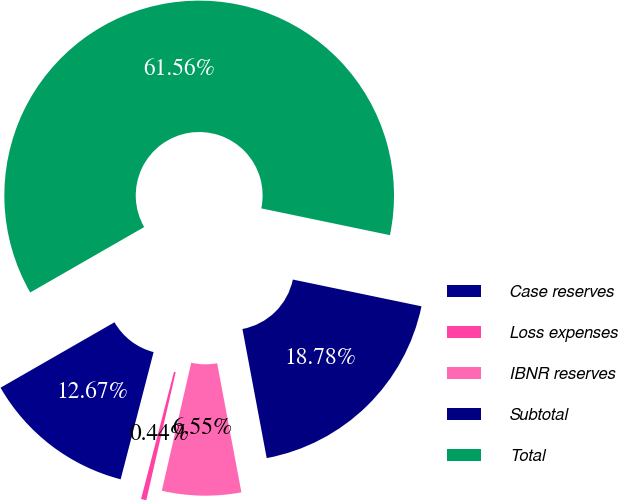Convert chart to OTSL. <chart><loc_0><loc_0><loc_500><loc_500><pie_chart><fcel>Case reserves<fcel>Loss expenses<fcel>IBNR reserves<fcel>Subtotal<fcel>Total<nl><fcel>12.67%<fcel>0.44%<fcel>6.55%<fcel>18.78%<fcel>61.56%<nl></chart> 